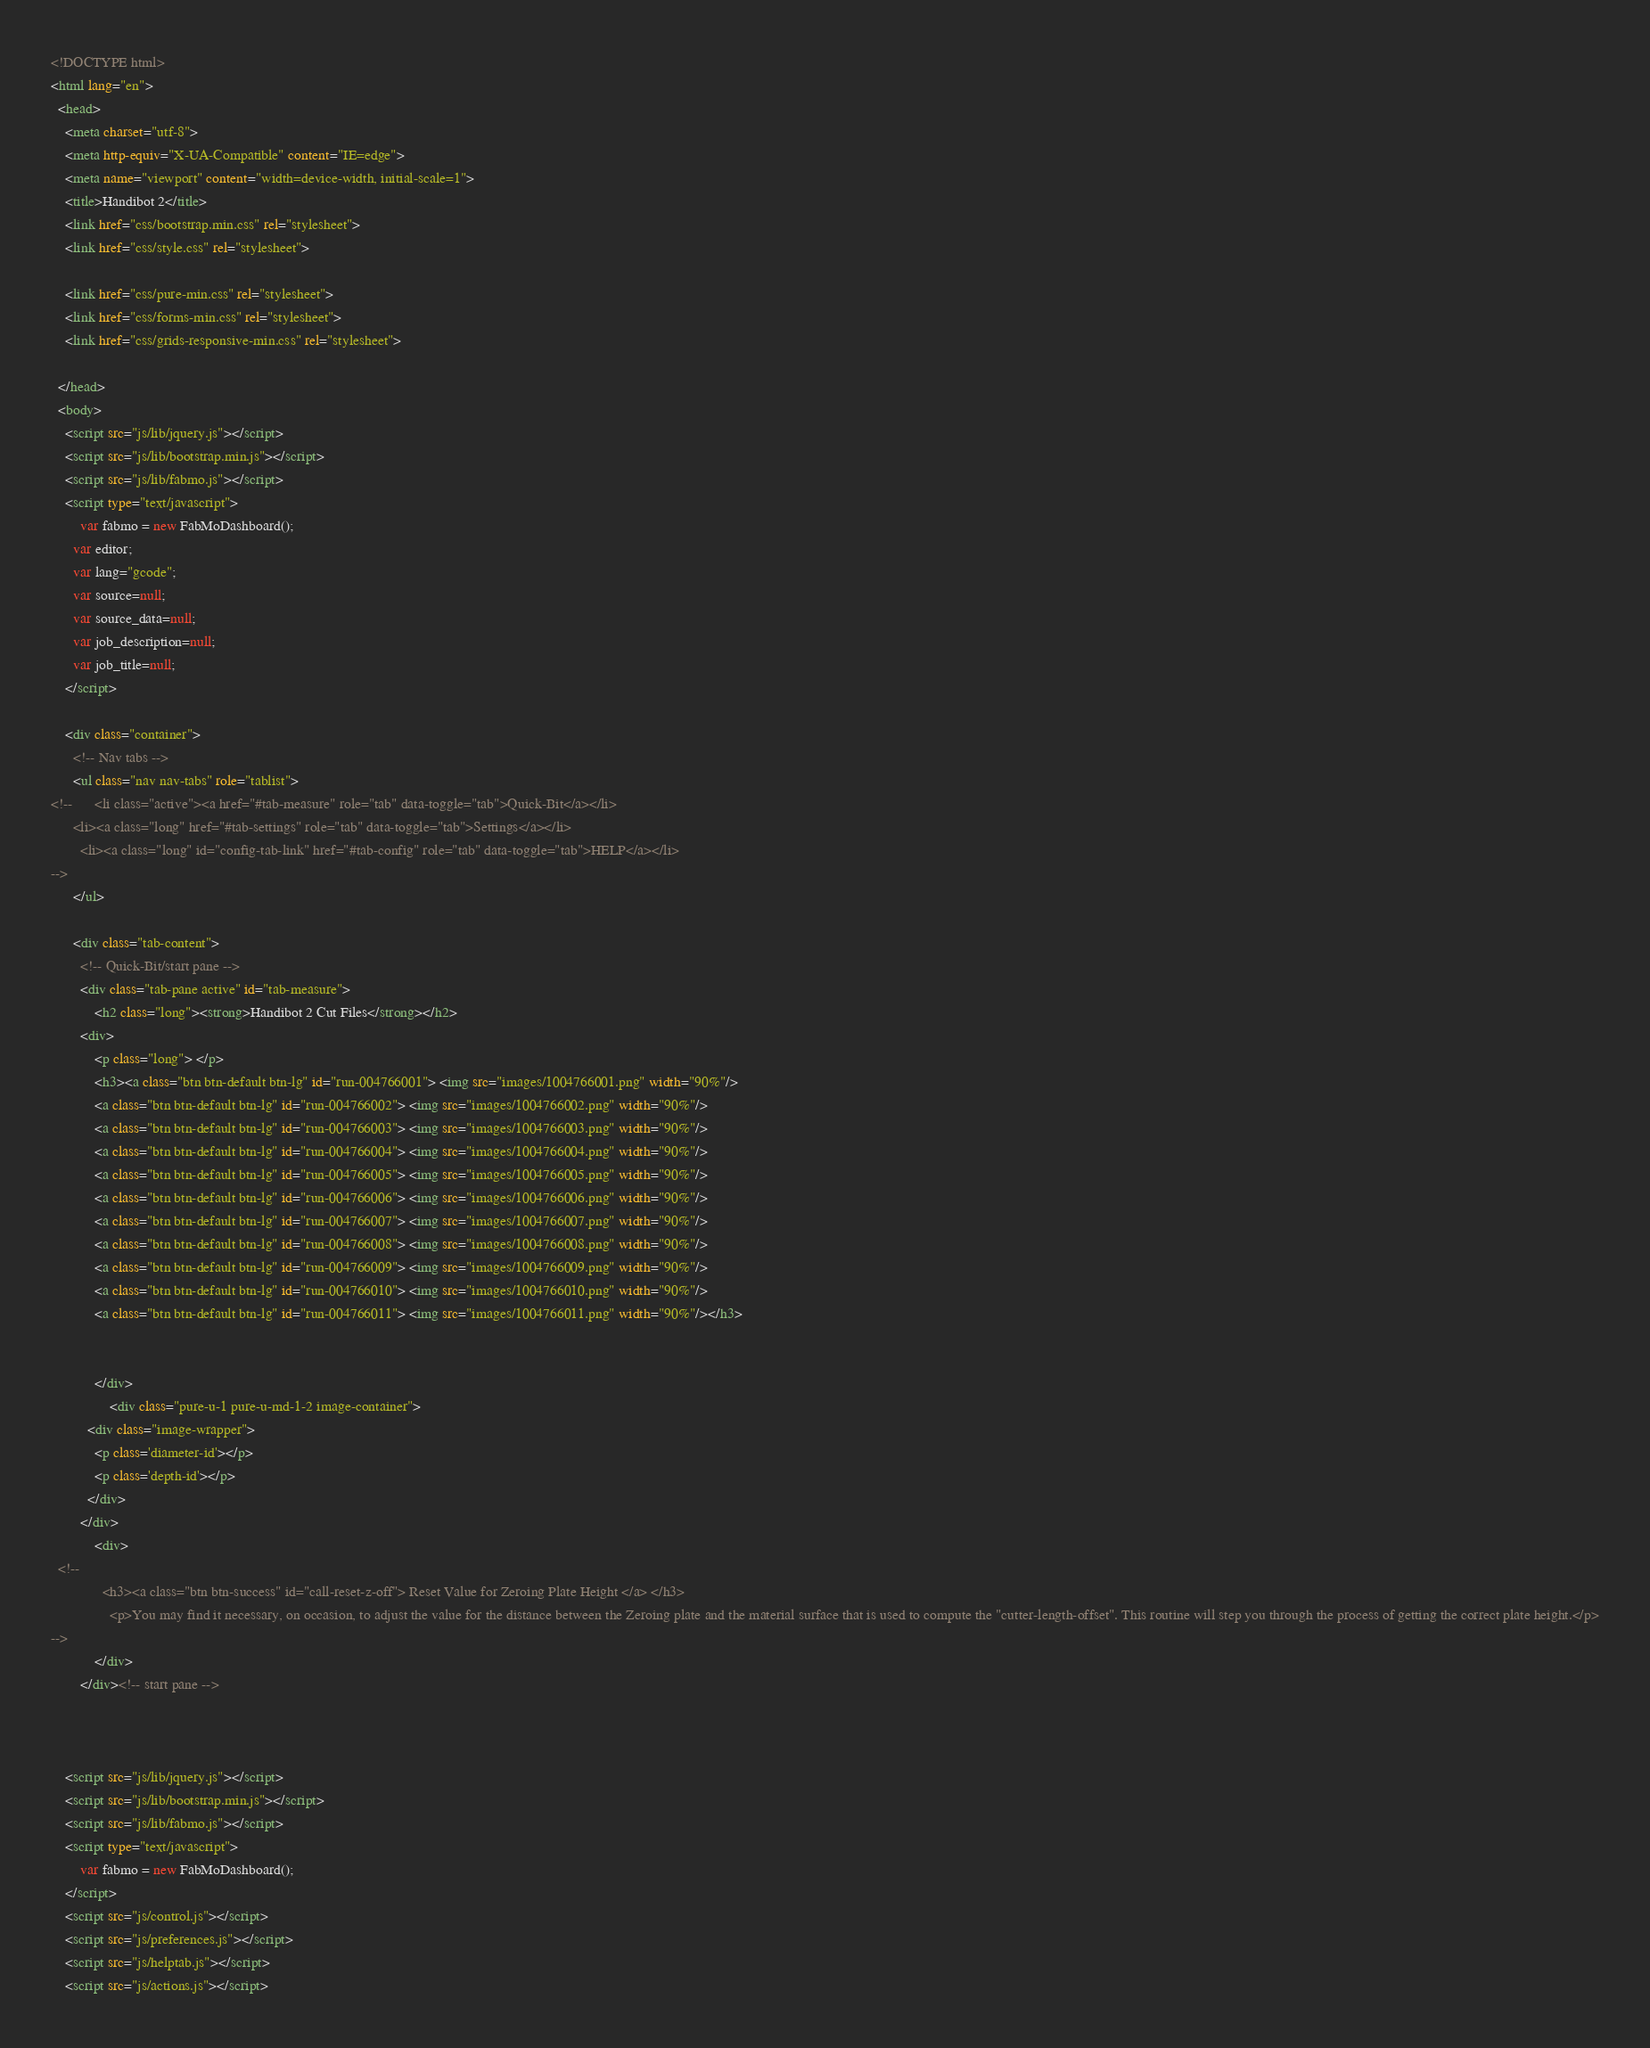<code> <loc_0><loc_0><loc_500><loc_500><_HTML_><!DOCTYPE html>
<html lang="en">
  <head>
    <meta charset="utf-8">
    <meta http-equiv="X-UA-Compatible" content="IE=edge">
    <meta name="viewport" content="width=device-width, initial-scale=1">
    <title>Handibot 2</title>
    <link href="css/bootstrap.min.css" rel="stylesheet">
    <link href="css/style.css" rel="stylesheet">

    <link href="css/pure-min.css" rel="stylesheet">
    <link href="css/forms-min.css" rel="stylesheet">
    <link href="css/grids-responsive-min.css" rel="stylesheet">

  </head>
  <body>
	<script src="js/lib/jquery.js"></script>
    <script src="js/lib/bootstrap.min.js"></script>
    <script src="js/lib/fabmo.js"></script>
  	<script type="text/javascript">
  		var fabmo = new FabMoDashboard();
      var editor;
      var lang="gcode";
      var source=null;
      var source_data=null;
      var job_description=null;
      var job_title=null;
  	</script>

    <div class="container">
      <!-- Nav tabs -->
	  <ul class="nav nav-tabs" role="tablist">
<!--      <li class="active"><a href="#tab-measure" role="tab" data-toggle="tab">Quick-Bit</a></li>
      <li><a class="long" href="#tab-settings" role="tab" data-toggle="tab">Settings</a></li>
        <li><a class="long" id="config-tab-link" href="#tab-config" role="tab" data-toggle="tab">HELP</a></li>
-->
      </ul>

      <div class="tab-content">
        <!-- Quick-Bit/start pane -->
        <div class="tab-pane active" id="tab-measure">
            <h2 class="long"><strong>Handibot 2 Cut Files</strong></h2>
        <div>
            <p class="long"> </p>
			<h3><a class="btn btn-default btn-lg" id="run-004766001"> <img src="images/1004766001.png" width="90%"/> 
			<a class="btn btn-default btn-lg" id="run-004766002"> <img src="images/1004766002.png" width="90%"/>
			<a class="btn btn-default btn-lg" id="run-004766003"> <img src="images/1004766003.png" width="90%"/>
			<a class="btn btn-default btn-lg" id="run-004766004"> <img src="images/1004766004.png" width="90%"/>
			<a class="btn btn-default btn-lg" id="run-004766005"> <img src="images/1004766005.png" width="90%"/>
			<a class="btn btn-default btn-lg" id="run-004766006"> <img src="images/1004766006.png" width="90%"/>
			<a class="btn btn-default btn-lg" id="run-004766007"> <img src="images/1004766007.png" width="90%"/>
			<a class="btn btn-default btn-lg" id="run-004766008"> <img src="images/1004766008.png" width="90%"/>
			<a class="btn btn-default btn-lg" id="run-004766009"> <img src="images/1004766009.png" width="90%"/>
			<a class="btn btn-default btn-lg" id="run-004766010"> <img src="images/1004766010.png" width="90%"/>
			<a class="btn btn-default btn-lg" id="run-004766011"> <img src="images/1004766011.png" width="90%"/></h3>

			  
            </div>
				<div class="pure-u-1 pure-u-md-1-2 image-container">
          <div class="image-wrapper">
            <p class='diameter-id'></p>
            <p class='depth-id'></p>
          </div>
        </div>  
            <div>
  <!--
              <h3><a class="btn btn-success" id="call-reset-z-off"> Reset Value for Zeroing Plate Height </a> </h3>
                <p>You may find it necessary, on occasion, to adjust the value for the distance between the Zeroing plate and the material surface that is used to compute the "cutter-length-offset". This routine will step you through the process of getting the correct plate height.</p>
-->
            </div>  
        </div><!-- start pane -->

        

    <script src="js/lib/jquery.js"></script>
    <script src="js/lib/bootstrap.min.js"></script>
    <script src="js/lib/fabmo.js"></script>
  	<script type="text/javascript">
  		var fabmo = new FabMoDashboard();
  	</script>
    <script src="js/control.js"></script>
    <script src="js/preferences.js"></script>
    <script src="js/helptab.js"></script>
    <script src="js/actions.js"></script></code> 